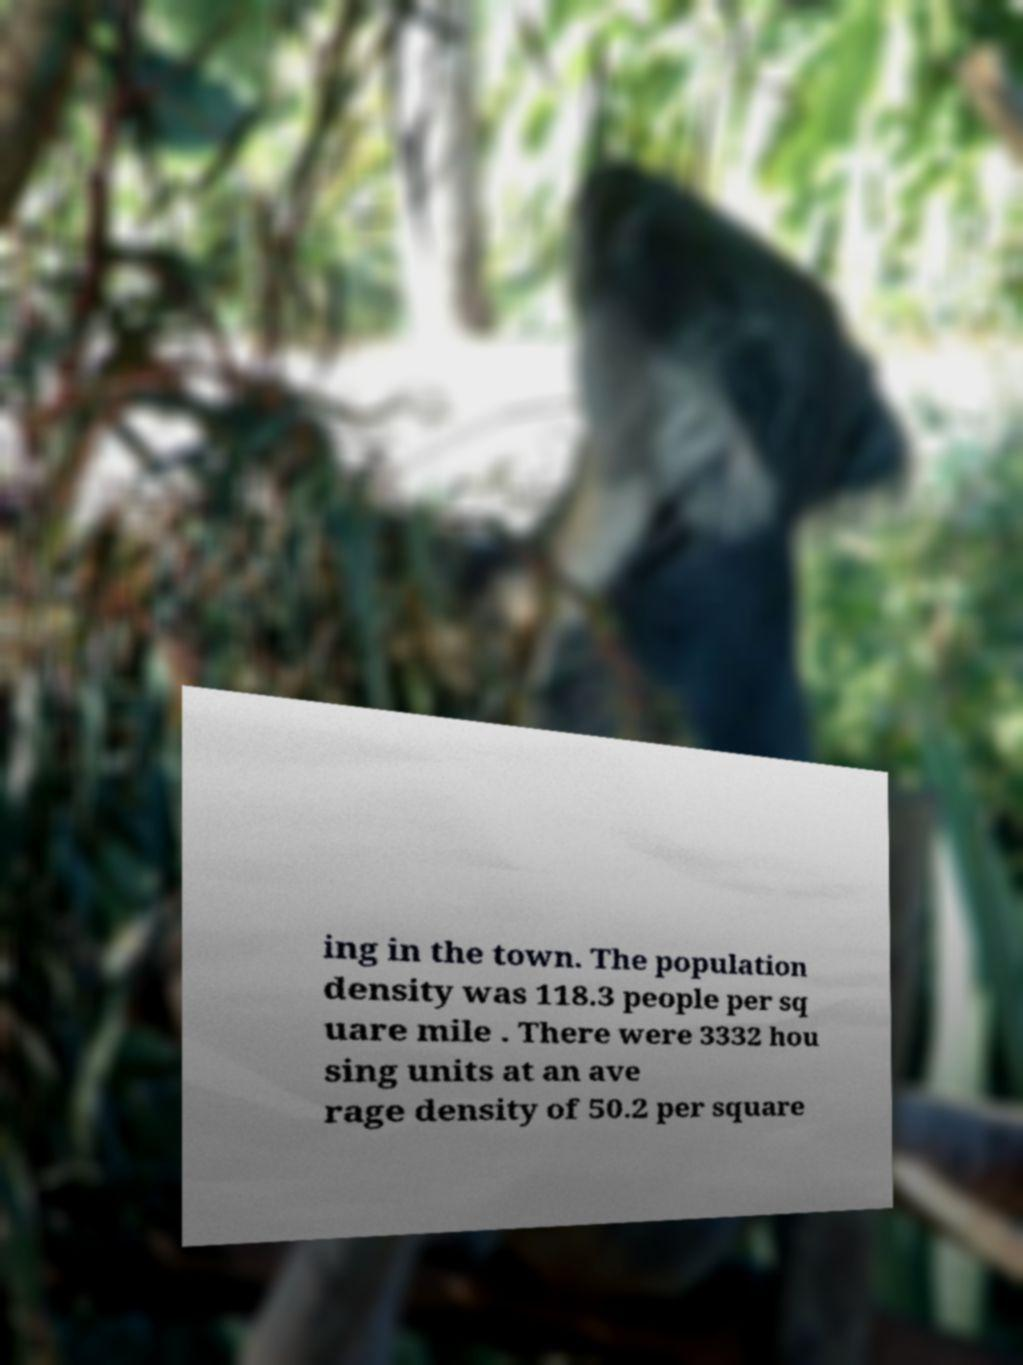Can you read and provide the text displayed in the image?This photo seems to have some interesting text. Can you extract and type it out for me? ing in the town. The population density was 118.3 people per sq uare mile . There were 3332 hou sing units at an ave rage density of 50.2 per square 